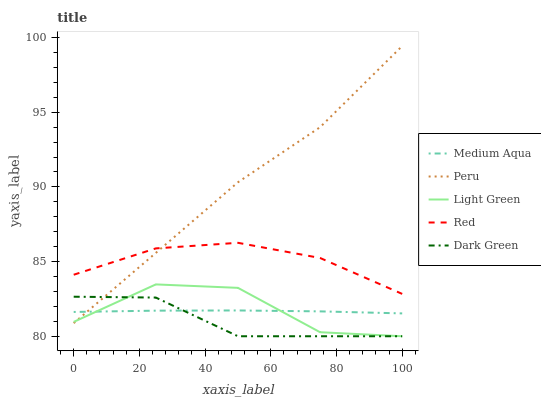Does Medium Aqua have the minimum area under the curve?
Answer yes or no. No. Does Medium Aqua have the maximum area under the curve?
Answer yes or no. No. Is Light Green the smoothest?
Answer yes or no. No. Is Medium Aqua the roughest?
Answer yes or no. No. Does Medium Aqua have the lowest value?
Answer yes or no. No. Does Light Green have the highest value?
Answer yes or no. No. Is Dark Green less than Red?
Answer yes or no. Yes. Is Red greater than Medium Aqua?
Answer yes or no. Yes. Does Dark Green intersect Red?
Answer yes or no. No. 